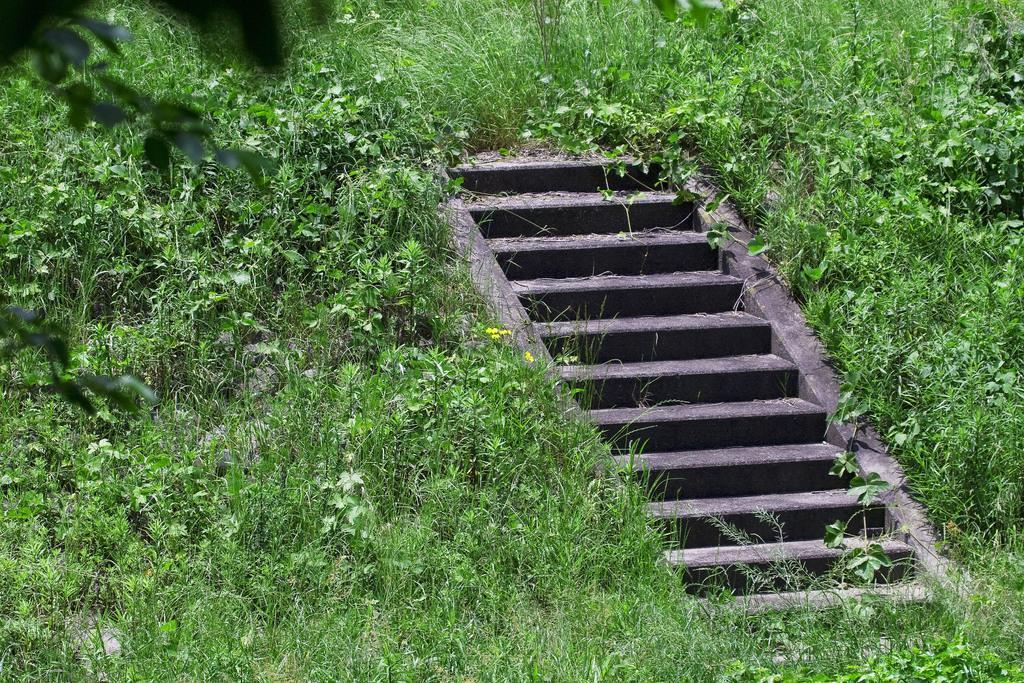Describe this image in one or two sentences. In this image there are cement steps in the middle of the ground and there are small plants and grass around the steps. 